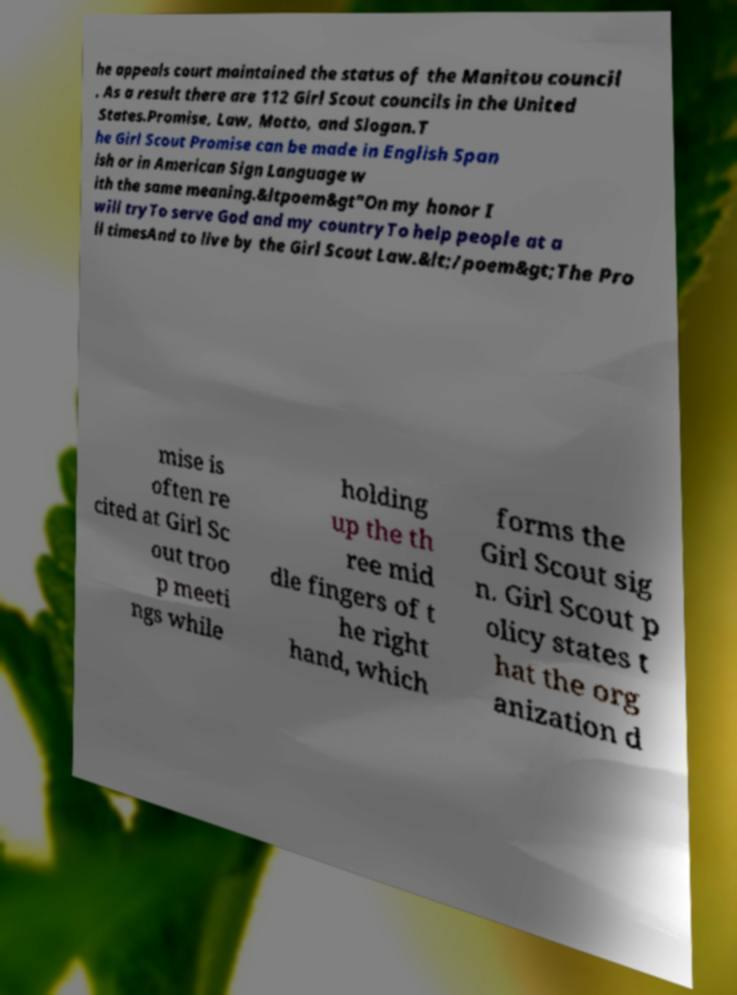Please read and relay the text visible in this image. What does it say? he appeals court maintained the status of the Manitou council . As a result there are 112 Girl Scout councils in the United States.Promise, Law, Motto, and Slogan.T he Girl Scout Promise can be made in English Span ish or in American Sign Language w ith the same meaning.&ltpoem&gt"On my honor I will tryTo serve God and my countryTo help people at a ll timesAnd to live by the Girl Scout Law.&lt;/poem&gt;The Pro mise is often re cited at Girl Sc out troo p meeti ngs while holding up the th ree mid dle fingers of t he right hand, which forms the Girl Scout sig n. Girl Scout p olicy states t hat the org anization d 